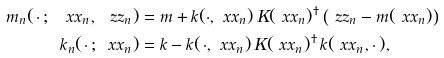<formula> <loc_0><loc_0><loc_500><loc_500>m _ { n } ( \, \cdot \, ; \, \ x x _ { n } , \ z z _ { n } ) & = m + k ( \cdot , \ x x _ { n } ) \, K ( \ x x _ { n } ) ^ { \dagger } \left ( \ z z _ { n } - m ( \ x x _ { n } ) \right ) \\ k _ { n } ( \, \cdot \, ; \, \ x x _ { n } ) & = k - k ( \, \cdot , \ x x _ { n } ) \, K ( \ x x _ { n } ) ^ { \dagger } \, k ( \ x x _ { n } , \cdot \, ) ,</formula> 